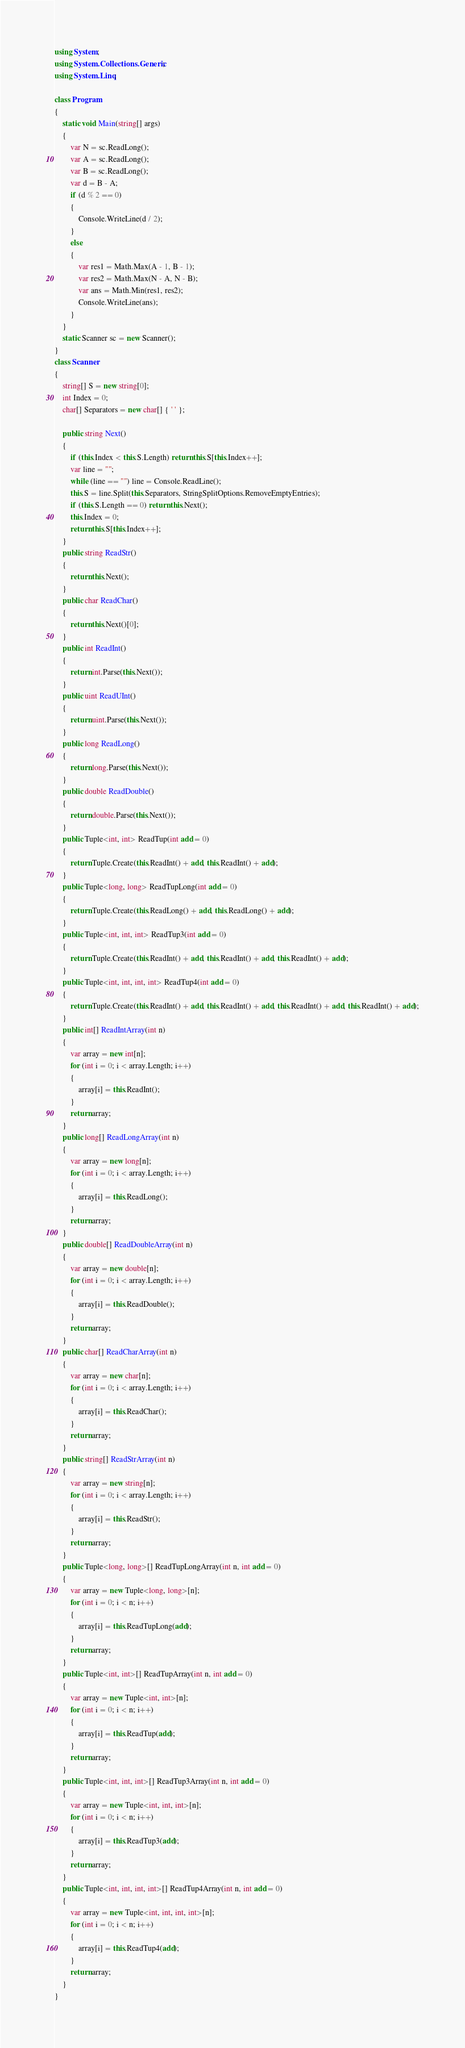Convert code to text. <code><loc_0><loc_0><loc_500><loc_500><_C#_>using System;
using System.Collections.Generic;
using System.Linq;

class Program
{
    static void Main(string[] args)
    {
        var N = sc.ReadLong();
        var A = sc.ReadLong();
        var B = sc.ReadLong();
        var d = B - A;
        if (d % 2 == 0)
        {
            Console.WriteLine(d / 2);
        }
        else
        {
            var res1 = Math.Max(A - 1, B - 1);
            var res2 = Math.Max(N - A, N - B);
            var ans = Math.Min(res1, res2);
            Console.WriteLine(ans);
        }
    }
    static Scanner sc = new Scanner();
}
class Scanner
{
    string[] S = new string[0];
    int Index = 0;
    char[] Separators = new char[] { ' ' };

    public string Next()
    {
        if (this.Index < this.S.Length) return this.S[this.Index++];
        var line = "";
        while (line == "") line = Console.ReadLine();
        this.S = line.Split(this.Separators, StringSplitOptions.RemoveEmptyEntries);
        if (this.S.Length == 0) return this.Next();
        this.Index = 0;
        return this.S[this.Index++];
    }
    public string ReadStr()
    {
        return this.Next();
    }
    public char ReadChar()
    {
        return this.Next()[0];
    }
    public int ReadInt()
    {
        return int.Parse(this.Next());
    }
    public uint ReadUInt()
    {
        return uint.Parse(this.Next());
    }
    public long ReadLong()
    {
        return long.Parse(this.Next());
    }
    public double ReadDouble()
    {
        return double.Parse(this.Next());
    }
    public Tuple<int, int> ReadTup(int add = 0)
    {
        return Tuple.Create(this.ReadInt() + add, this.ReadInt() + add);
    }
    public Tuple<long, long> ReadTupLong(int add = 0)
    {
        return Tuple.Create(this.ReadLong() + add, this.ReadLong() + add);
    }
    public Tuple<int, int, int> ReadTup3(int add = 0)
    {
        return Tuple.Create(this.ReadInt() + add, this.ReadInt() + add, this.ReadInt() + add);
    }
    public Tuple<int, int, int, int> ReadTup4(int add = 0)
    {
        return Tuple.Create(this.ReadInt() + add, this.ReadInt() + add, this.ReadInt() + add, this.ReadInt() + add);
    }
    public int[] ReadIntArray(int n)
    {
        var array = new int[n];
        for (int i = 0; i < array.Length; i++)
        {
            array[i] = this.ReadInt();
        }
        return array;
    }
    public long[] ReadLongArray(int n)
    {
        var array = new long[n];
        for (int i = 0; i < array.Length; i++)
        {
            array[i] = this.ReadLong();
        }
        return array;
    }
    public double[] ReadDoubleArray(int n)
    {
        var array = new double[n];
        for (int i = 0; i < array.Length; i++)
        {
            array[i] = this.ReadDouble();
        }
        return array;
    }
    public char[] ReadCharArray(int n)
    {
        var array = new char[n];
        for (int i = 0; i < array.Length; i++)
        {
            array[i] = this.ReadChar();
        }
        return array;
    }
    public string[] ReadStrArray(int n)
    {
        var array = new string[n];
        for (int i = 0; i < array.Length; i++)
        {
            array[i] = this.ReadStr();
        }
        return array;
    }
    public Tuple<long, long>[] ReadTupLongArray(int n, int add = 0)
    {
        var array = new Tuple<long, long>[n];
        for (int i = 0; i < n; i++)
        {
            array[i] = this.ReadTupLong(add);
        }
        return array;
    }
    public Tuple<int, int>[] ReadTupArray(int n, int add = 0)
    {
        var array = new Tuple<int, int>[n];
        for (int i = 0; i < n; i++)
        {
            array[i] = this.ReadTup(add);
        }
        return array;
    }
    public Tuple<int, int, int>[] ReadTup3Array(int n, int add = 0)
    {
        var array = new Tuple<int, int, int>[n];
        for (int i = 0; i < n; i++)
        {
            array[i] = this.ReadTup3(add);
        }
        return array;
    }
    public Tuple<int, int, int, int>[] ReadTup4Array(int n, int add = 0)
    {
        var array = new Tuple<int, int, int, int>[n];
        for (int i = 0; i < n; i++)
        {
            array[i] = this.ReadTup4(add);
        }
        return array;
    }
}
</code> 